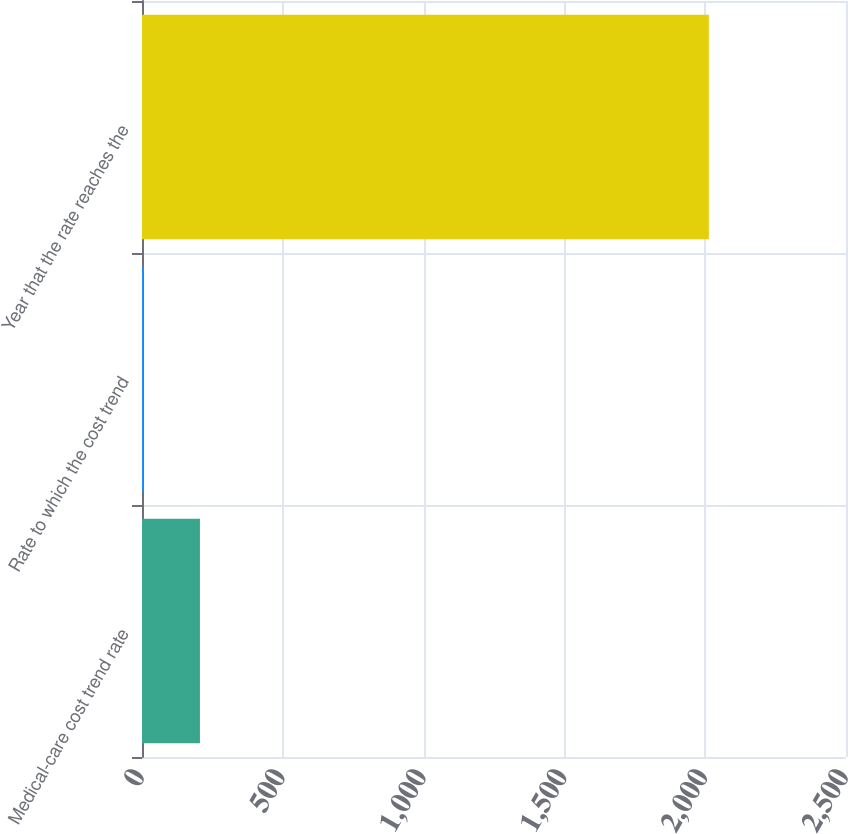Convert chart to OTSL. <chart><loc_0><loc_0><loc_500><loc_500><bar_chart><fcel>Medical-care cost trend rate<fcel>Rate to which the cost trend<fcel>Year that the rate reaches the<nl><fcel>205.8<fcel>5<fcel>2013<nl></chart> 